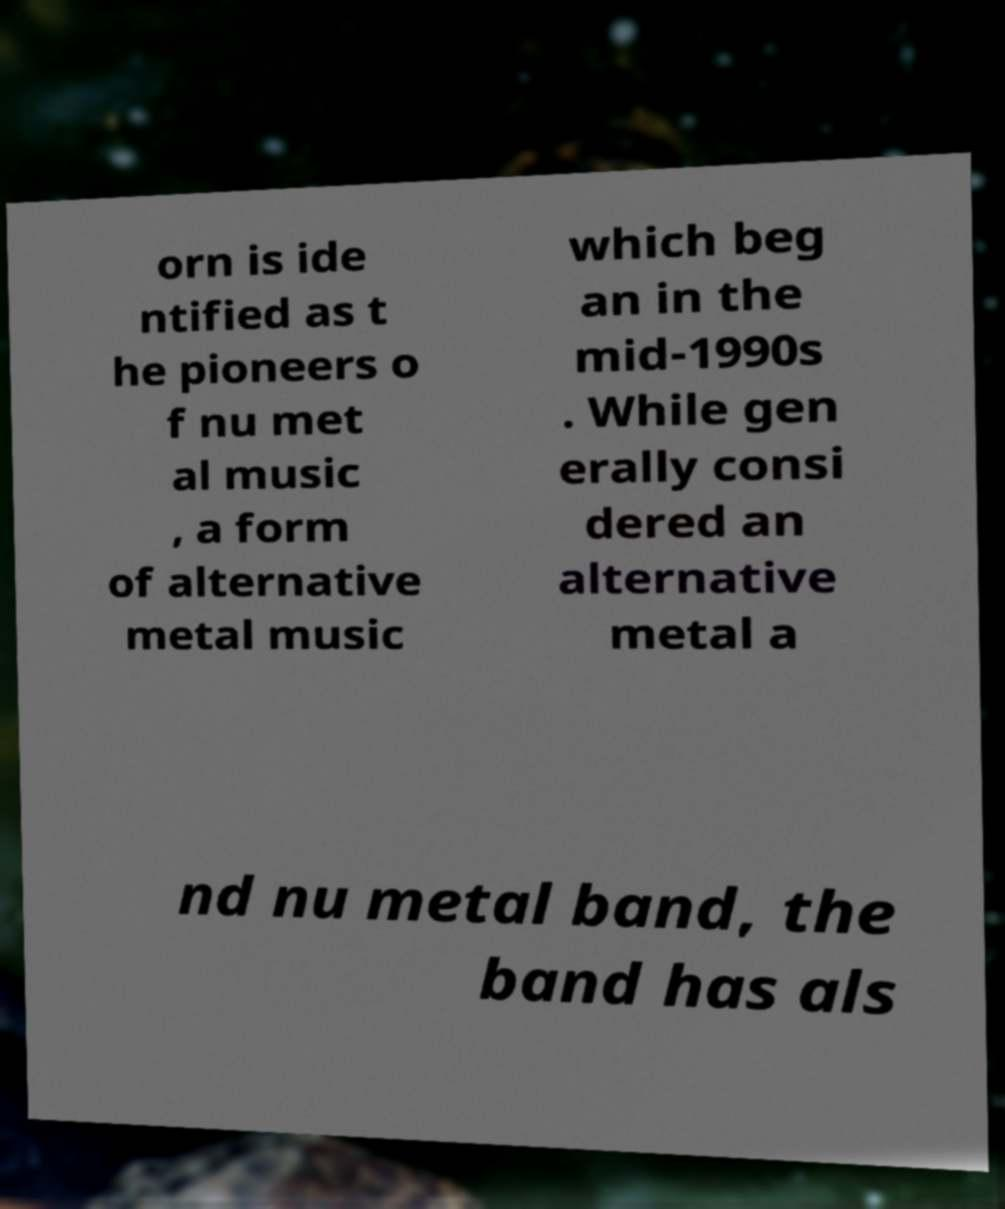Please identify and transcribe the text found in this image. orn is ide ntified as t he pioneers o f nu met al music , a form of alternative metal music which beg an in the mid-1990s . While gen erally consi dered an alternative metal a nd nu metal band, the band has als 